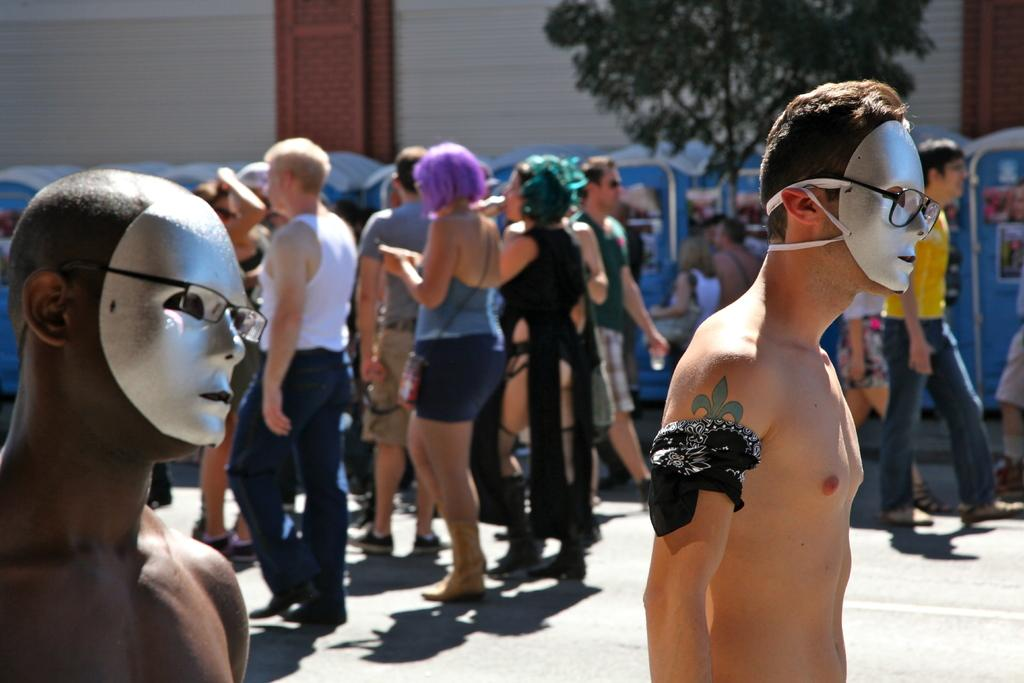What can be seen in the foreground of the image? There are two men with masks on their faces in the foreground. What is happening in the background of the image? There are people walking on the road in the background. What natural element is visible in the image? There is a tree visible at the top of the image. What type of club is being used by the people in the image? There is no club visible in the image; the two men in the foreground are wearing masks. What things are the people walking on the road carrying in the image? The provided facts do not mention any specific items being carried by the people walking on the road in the background. 